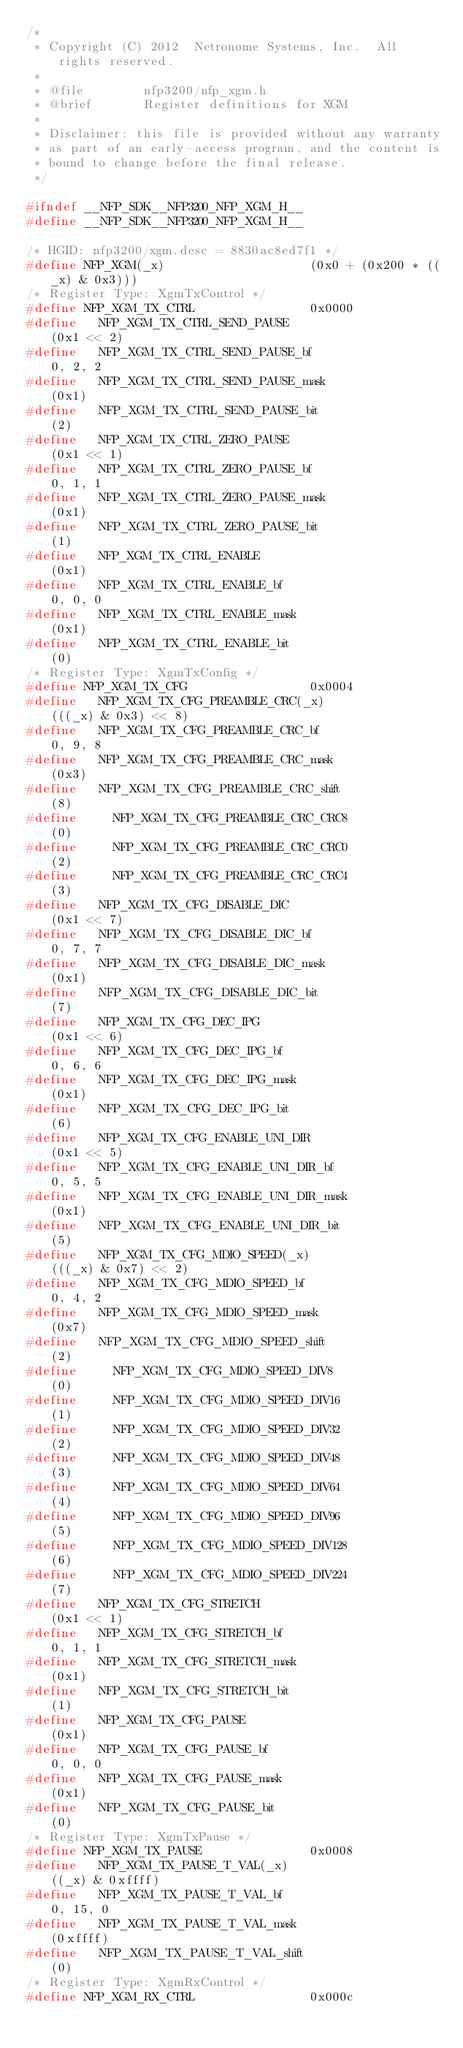Convert code to text. <code><loc_0><loc_0><loc_500><loc_500><_C_>/*
 * Copyright (C) 2012  Netronome Systems, Inc.  All rights reserved.
 *
 * @file        nfp3200/nfp_xgm.h
 * @brief       Register definitions for XGM
 *
 * Disclaimer: this file is provided without any warranty
 * as part of an early-access program, and the content is
 * bound to change before the final release.
 */

#ifndef __NFP_SDK__NFP3200_NFP_XGM_H__
#define __NFP_SDK__NFP3200_NFP_XGM_H__

/* HGID: nfp3200/xgm.desc = 8830ac8ed7f1 */
#define NFP_XGM(_x)                    (0x0 + (0x200 * ((_x) & 0x3)))
/* Register Type: XgmTxControl */
#define NFP_XGM_TX_CTRL                0x0000
#define   NFP_XGM_TX_CTRL_SEND_PAUSE                    (0x1 << 2)
#define   NFP_XGM_TX_CTRL_SEND_PAUSE_bf                 0, 2, 2
#define   NFP_XGM_TX_CTRL_SEND_PAUSE_mask               (0x1)
#define   NFP_XGM_TX_CTRL_SEND_PAUSE_bit                (2)
#define   NFP_XGM_TX_CTRL_ZERO_PAUSE                    (0x1 << 1)
#define   NFP_XGM_TX_CTRL_ZERO_PAUSE_bf                 0, 1, 1
#define   NFP_XGM_TX_CTRL_ZERO_PAUSE_mask               (0x1)
#define   NFP_XGM_TX_CTRL_ZERO_PAUSE_bit                (1)
#define   NFP_XGM_TX_CTRL_ENABLE                        (0x1)
#define   NFP_XGM_TX_CTRL_ENABLE_bf                     0, 0, 0
#define   NFP_XGM_TX_CTRL_ENABLE_mask                   (0x1)
#define   NFP_XGM_TX_CTRL_ENABLE_bit                    (0)
/* Register Type: XgmTxConfig */
#define NFP_XGM_TX_CFG                 0x0004
#define   NFP_XGM_TX_CFG_PREAMBLE_CRC(_x)               (((_x) & 0x3) << 8)
#define   NFP_XGM_TX_CFG_PREAMBLE_CRC_bf                0, 9, 8
#define   NFP_XGM_TX_CFG_PREAMBLE_CRC_mask              (0x3)
#define   NFP_XGM_TX_CFG_PREAMBLE_CRC_shift             (8)
#define     NFP_XGM_TX_CFG_PREAMBLE_CRC_CRC8            (0)
#define     NFP_XGM_TX_CFG_PREAMBLE_CRC_CRC0            (2)
#define     NFP_XGM_TX_CFG_PREAMBLE_CRC_CRC4            (3)
#define   NFP_XGM_TX_CFG_DISABLE_DIC                    (0x1 << 7)
#define   NFP_XGM_TX_CFG_DISABLE_DIC_bf                 0, 7, 7
#define   NFP_XGM_TX_CFG_DISABLE_DIC_mask               (0x1)
#define   NFP_XGM_TX_CFG_DISABLE_DIC_bit                (7)
#define   NFP_XGM_TX_CFG_DEC_IPG                        (0x1 << 6)
#define   NFP_XGM_TX_CFG_DEC_IPG_bf                     0, 6, 6
#define   NFP_XGM_TX_CFG_DEC_IPG_mask                   (0x1)
#define   NFP_XGM_TX_CFG_DEC_IPG_bit                    (6)
#define   NFP_XGM_TX_CFG_ENABLE_UNI_DIR                 (0x1 << 5)
#define   NFP_XGM_TX_CFG_ENABLE_UNI_DIR_bf              0, 5, 5
#define   NFP_XGM_TX_CFG_ENABLE_UNI_DIR_mask            (0x1)
#define   NFP_XGM_TX_CFG_ENABLE_UNI_DIR_bit             (5)
#define   NFP_XGM_TX_CFG_MDIO_SPEED(_x)                 (((_x) & 0x7) << 2)
#define   NFP_XGM_TX_CFG_MDIO_SPEED_bf                  0, 4, 2
#define   NFP_XGM_TX_CFG_MDIO_SPEED_mask                (0x7)
#define   NFP_XGM_TX_CFG_MDIO_SPEED_shift               (2)
#define     NFP_XGM_TX_CFG_MDIO_SPEED_DIV8              (0)
#define     NFP_XGM_TX_CFG_MDIO_SPEED_DIV16             (1)
#define     NFP_XGM_TX_CFG_MDIO_SPEED_DIV32             (2)
#define     NFP_XGM_TX_CFG_MDIO_SPEED_DIV48             (3)
#define     NFP_XGM_TX_CFG_MDIO_SPEED_DIV64             (4)
#define     NFP_XGM_TX_CFG_MDIO_SPEED_DIV96             (5)
#define     NFP_XGM_TX_CFG_MDIO_SPEED_DIV128            (6)
#define     NFP_XGM_TX_CFG_MDIO_SPEED_DIV224            (7)
#define   NFP_XGM_TX_CFG_STRETCH                        (0x1 << 1)
#define   NFP_XGM_TX_CFG_STRETCH_bf                     0, 1, 1
#define   NFP_XGM_TX_CFG_STRETCH_mask                   (0x1)
#define   NFP_XGM_TX_CFG_STRETCH_bit                    (1)
#define   NFP_XGM_TX_CFG_PAUSE                          (0x1)
#define   NFP_XGM_TX_CFG_PAUSE_bf                       0, 0, 0
#define   NFP_XGM_TX_CFG_PAUSE_mask                     (0x1)
#define   NFP_XGM_TX_CFG_PAUSE_bit                      (0)
/* Register Type: XgmTxPause */
#define NFP_XGM_TX_PAUSE               0x0008
#define   NFP_XGM_TX_PAUSE_T_VAL(_x)                    ((_x) & 0xffff)
#define   NFP_XGM_TX_PAUSE_T_VAL_bf                     0, 15, 0
#define   NFP_XGM_TX_PAUSE_T_VAL_mask                   (0xffff)
#define   NFP_XGM_TX_PAUSE_T_VAL_shift                  (0)
/* Register Type: XgmRxControl */
#define NFP_XGM_RX_CTRL                0x000c</code> 